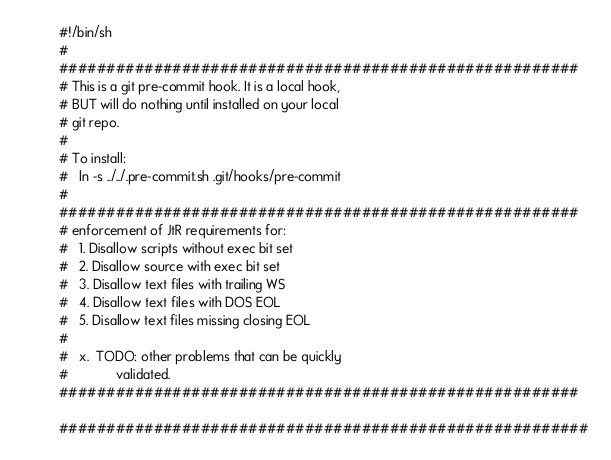Convert code to text. <code><loc_0><loc_0><loc_500><loc_500><_Bash_>#!/bin/sh
#
#######################################################
# This is a git pre-commit hook. It is a local hook,
# BUT will do nothing until installed on your local
# git repo.
#
# To install:
#   ln -s ../../.pre-commit.sh .git/hooks/pre-commit
#
#######################################################
# enforcement of JtR requirements for:
#   1. Disallow scripts without exec bit set
#   2. Disallow source with exec bit set
#   3. Disallow text files with trailing WS
#   4. Disallow text files with DOS EOL
#   5. Disallow text files missing closing EOL
#
#   x.  TODO: other problems that can be quickly
#             validated.
#######################################################

########################################################</code> 